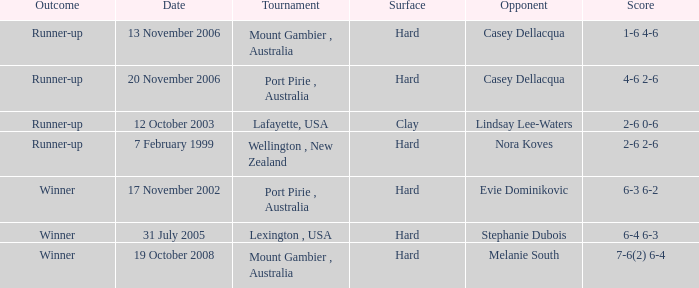On november 17, 2002, who is the competitor? Evie Dominikovic. 